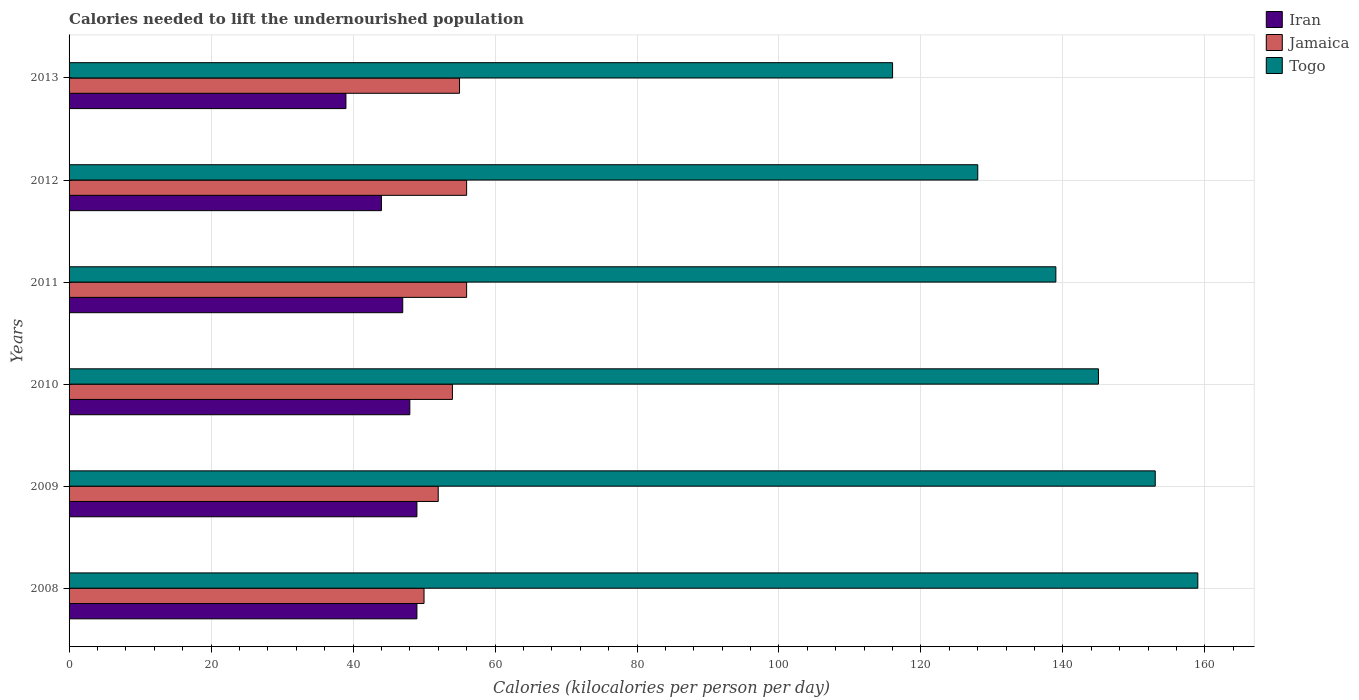How many different coloured bars are there?
Ensure brevity in your answer.  3. How many groups of bars are there?
Offer a very short reply. 6. Are the number of bars per tick equal to the number of legend labels?
Give a very brief answer. Yes. Are the number of bars on each tick of the Y-axis equal?
Offer a terse response. Yes. How many bars are there on the 1st tick from the top?
Give a very brief answer. 3. How many bars are there on the 2nd tick from the bottom?
Make the answer very short. 3. What is the label of the 6th group of bars from the top?
Provide a succinct answer. 2008. In how many cases, is the number of bars for a given year not equal to the number of legend labels?
Your response must be concise. 0. What is the total calories needed to lift the undernourished population in Togo in 2009?
Your answer should be very brief. 153. Across all years, what is the maximum total calories needed to lift the undernourished population in Jamaica?
Your answer should be very brief. 56. Across all years, what is the minimum total calories needed to lift the undernourished population in Iran?
Your answer should be very brief. 39. In which year was the total calories needed to lift the undernourished population in Iran maximum?
Provide a short and direct response. 2008. In which year was the total calories needed to lift the undernourished population in Togo minimum?
Offer a very short reply. 2013. What is the total total calories needed to lift the undernourished population in Iran in the graph?
Give a very brief answer. 276. What is the difference between the total calories needed to lift the undernourished population in Togo in 2008 and that in 2012?
Ensure brevity in your answer.  31. What is the difference between the total calories needed to lift the undernourished population in Iran in 2009 and the total calories needed to lift the undernourished population in Jamaica in 2008?
Offer a terse response. -1. In the year 2008, what is the difference between the total calories needed to lift the undernourished population in Togo and total calories needed to lift the undernourished population in Jamaica?
Provide a short and direct response. 109. What is the ratio of the total calories needed to lift the undernourished population in Togo in 2011 to that in 2012?
Your answer should be very brief. 1.09. What is the difference between the highest and the second highest total calories needed to lift the undernourished population in Iran?
Your response must be concise. 0. What is the difference between the highest and the lowest total calories needed to lift the undernourished population in Togo?
Provide a short and direct response. 43. In how many years, is the total calories needed to lift the undernourished population in Iran greater than the average total calories needed to lift the undernourished population in Iran taken over all years?
Provide a succinct answer. 4. Is the sum of the total calories needed to lift the undernourished population in Iran in 2011 and 2013 greater than the maximum total calories needed to lift the undernourished population in Togo across all years?
Make the answer very short. No. What does the 1st bar from the top in 2010 represents?
Make the answer very short. Togo. What does the 2nd bar from the bottom in 2010 represents?
Provide a short and direct response. Jamaica. How many bars are there?
Offer a very short reply. 18. Are all the bars in the graph horizontal?
Provide a short and direct response. Yes. How many years are there in the graph?
Provide a short and direct response. 6. What is the difference between two consecutive major ticks on the X-axis?
Keep it short and to the point. 20. Are the values on the major ticks of X-axis written in scientific E-notation?
Your answer should be very brief. No. Does the graph contain any zero values?
Provide a succinct answer. No. Does the graph contain grids?
Your answer should be compact. Yes. What is the title of the graph?
Your answer should be compact. Calories needed to lift the undernourished population. Does "Spain" appear as one of the legend labels in the graph?
Offer a terse response. No. What is the label or title of the X-axis?
Provide a short and direct response. Calories (kilocalories per person per day). What is the label or title of the Y-axis?
Your answer should be compact. Years. What is the Calories (kilocalories per person per day) of Iran in 2008?
Keep it short and to the point. 49. What is the Calories (kilocalories per person per day) in Togo in 2008?
Give a very brief answer. 159. What is the Calories (kilocalories per person per day) in Jamaica in 2009?
Your response must be concise. 52. What is the Calories (kilocalories per person per day) of Togo in 2009?
Give a very brief answer. 153. What is the Calories (kilocalories per person per day) of Iran in 2010?
Ensure brevity in your answer.  48. What is the Calories (kilocalories per person per day) of Togo in 2010?
Provide a short and direct response. 145. What is the Calories (kilocalories per person per day) in Jamaica in 2011?
Make the answer very short. 56. What is the Calories (kilocalories per person per day) of Togo in 2011?
Provide a succinct answer. 139. What is the Calories (kilocalories per person per day) of Iran in 2012?
Offer a terse response. 44. What is the Calories (kilocalories per person per day) of Jamaica in 2012?
Make the answer very short. 56. What is the Calories (kilocalories per person per day) in Togo in 2012?
Provide a succinct answer. 128. What is the Calories (kilocalories per person per day) of Jamaica in 2013?
Your answer should be very brief. 55. What is the Calories (kilocalories per person per day) of Togo in 2013?
Provide a short and direct response. 116. Across all years, what is the maximum Calories (kilocalories per person per day) in Togo?
Offer a terse response. 159. Across all years, what is the minimum Calories (kilocalories per person per day) of Iran?
Your answer should be compact. 39. Across all years, what is the minimum Calories (kilocalories per person per day) in Jamaica?
Ensure brevity in your answer.  50. Across all years, what is the minimum Calories (kilocalories per person per day) in Togo?
Keep it short and to the point. 116. What is the total Calories (kilocalories per person per day) of Iran in the graph?
Offer a terse response. 276. What is the total Calories (kilocalories per person per day) of Jamaica in the graph?
Ensure brevity in your answer.  323. What is the total Calories (kilocalories per person per day) of Togo in the graph?
Provide a short and direct response. 840. What is the difference between the Calories (kilocalories per person per day) in Jamaica in 2008 and that in 2009?
Provide a succinct answer. -2. What is the difference between the Calories (kilocalories per person per day) of Togo in 2008 and that in 2009?
Keep it short and to the point. 6. What is the difference between the Calories (kilocalories per person per day) in Iran in 2008 and that in 2010?
Your answer should be compact. 1. What is the difference between the Calories (kilocalories per person per day) of Togo in 2008 and that in 2010?
Offer a terse response. 14. What is the difference between the Calories (kilocalories per person per day) in Togo in 2008 and that in 2011?
Offer a very short reply. 20. What is the difference between the Calories (kilocalories per person per day) in Iran in 2008 and that in 2012?
Provide a succinct answer. 5. What is the difference between the Calories (kilocalories per person per day) of Togo in 2008 and that in 2012?
Your response must be concise. 31. What is the difference between the Calories (kilocalories per person per day) in Iran in 2009 and that in 2011?
Give a very brief answer. 2. What is the difference between the Calories (kilocalories per person per day) of Jamaica in 2009 and that in 2011?
Offer a terse response. -4. What is the difference between the Calories (kilocalories per person per day) in Iran in 2009 and that in 2012?
Offer a very short reply. 5. What is the difference between the Calories (kilocalories per person per day) of Jamaica in 2009 and that in 2012?
Provide a succinct answer. -4. What is the difference between the Calories (kilocalories per person per day) of Iran in 2009 and that in 2013?
Give a very brief answer. 10. What is the difference between the Calories (kilocalories per person per day) of Jamaica in 2009 and that in 2013?
Make the answer very short. -3. What is the difference between the Calories (kilocalories per person per day) in Iran in 2010 and that in 2011?
Provide a succinct answer. 1. What is the difference between the Calories (kilocalories per person per day) of Togo in 2010 and that in 2011?
Provide a short and direct response. 6. What is the difference between the Calories (kilocalories per person per day) of Togo in 2010 and that in 2012?
Your answer should be very brief. 17. What is the difference between the Calories (kilocalories per person per day) in Iran in 2010 and that in 2013?
Your answer should be very brief. 9. What is the difference between the Calories (kilocalories per person per day) in Jamaica in 2010 and that in 2013?
Ensure brevity in your answer.  -1. What is the difference between the Calories (kilocalories per person per day) of Iran in 2011 and that in 2012?
Your answer should be compact. 3. What is the difference between the Calories (kilocalories per person per day) of Jamaica in 2011 and that in 2013?
Your response must be concise. 1. What is the difference between the Calories (kilocalories per person per day) in Iran in 2012 and that in 2013?
Your answer should be very brief. 5. What is the difference between the Calories (kilocalories per person per day) in Togo in 2012 and that in 2013?
Your answer should be compact. 12. What is the difference between the Calories (kilocalories per person per day) of Iran in 2008 and the Calories (kilocalories per person per day) of Jamaica in 2009?
Make the answer very short. -3. What is the difference between the Calories (kilocalories per person per day) of Iran in 2008 and the Calories (kilocalories per person per day) of Togo in 2009?
Your answer should be compact. -104. What is the difference between the Calories (kilocalories per person per day) of Jamaica in 2008 and the Calories (kilocalories per person per day) of Togo in 2009?
Keep it short and to the point. -103. What is the difference between the Calories (kilocalories per person per day) of Iran in 2008 and the Calories (kilocalories per person per day) of Jamaica in 2010?
Provide a succinct answer. -5. What is the difference between the Calories (kilocalories per person per day) of Iran in 2008 and the Calories (kilocalories per person per day) of Togo in 2010?
Ensure brevity in your answer.  -96. What is the difference between the Calories (kilocalories per person per day) of Jamaica in 2008 and the Calories (kilocalories per person per day) of Togo in 2010?
Your answer should be very brief. -95. What is the difference between the Calories (kilocalories per person per day) of Iran in 2008 and the Calories (kilocalories per person per day) of Jamaica in 2011?
Offer a very short reply. -7. What is the difference between the Calories (kilocalories per person per day) in Iran in 2008 and the Calories (kilocalories per person per day) in Togo in 2011?
Your answer should be compact. -90. What is the difference between the Calories (kilocalories per person per day) of Jamaica in 2008 and the Calories (kilocalories per person per day) of Togo in 2011?
Your answer should be compact. -89. What is the difference between the Calories (kilocalories per person per day) of Iran in 2008 and the Calories (kilocalories per person per day) of Jamaica in 2012?
Make the answer very short. -7. What is the difference between the Calories (kilocalories per person per day) of Iran in 2008 and the Calories (kilocalories per person per day) of Togo in 2012?
Your response must be concise. -79. What is the difference between the Calories (kilocalories per person per day) of Jamaica in 2008 and the Calories (kilocalories per person per day) of Togo in 2012?
Your response must be concise. -78. What is the difference between the Calories (kilocalories per person per day) of Iran in 2008 and the Calories (kilocalories per person per day) of Togo in 2013?
Give a very brief answer. -67. What is the difference between the Calories (kilocalories per person per day) of Jamaica in 2008 and the Calories (kilocalories per person per day) of Togo in 2013?
Give a very brief answer. -66. What is the difference between the Calories (kilocalories per person per day) in Iran in 2009 and the Calories (kilocalories per person per day) in Jamaica in 2010?
Make the answer very short. -5. What is the difference between the Calories (kilocalories per person per day) of Iran in 2009 and the Calories (kilocalories per person per day) of Togo in 2010?
Your answer should be very brief. -96. What is the difference between the Calories (kilocalories per person per day) in Jamaica in 2009 and the Calories (kilocalories per person per day) in Togo in 2010?
Provide a short and direct response. -93. What is the difference between the Calories (kilocalories per person per day) in Iran in 2009 and the Calories (kilocalories per person per day) in Togo in 2011?
Keep it short and to the point. -90. What is the difference between the Calories (kilocalories per person per day) of Jamaica in 2009 and the Calories (kilocalories per person per day) of Togo in 2011?
Give a very brief answer. -87. What is the difference between the Calories (kilocalories per person per day) in Iran in 2009 and the Calories (kilocalories per person per day) in Jamaica in 2012?
Give a very brief answer. -7. What is the difference between the Calories (kilocalories per person per day) in Iran in 2009 and the Calories (kilocalories per person per day) in Togo in 2012?
Your answer should be very brief. -79. What is the difference between the Calories (kilocalories per person per day) of Jamaica in 2009 and the Calories (kilocalories per person per day) of Togo in 2012?
Provide a short and direct response. -76. What is the difference between the Calories (kilocalories per person per day) in Iran in 2009 and the Calories (kilocalories per person per day) in Togo in 2013?
Make the answer very short. -67. What is the difference between the Calories (kilocalories per person per day) in Jamaica in 2009 and the Calories (kilocalories per person per day) in Togo in 2013?
Your answer should be compact. -64. What is the difference between the Calories (kilocalories per person per day) in Iran in 2010 and the Calories (kilocalories per person per day) in Togo in 2011?
Provide a short and direct response. -91. What is the difference between the Calories (kilocalories per person per day) of Jamaica in 2010 and the Calories (kilocalories per person per day) of Togo in 2011?
Make the answer very short. -85. What is the difference between the Calories (kilocalories per person per day) in Iran in 2010 and the Calories (kilocalories per person per day) in Togo in 2012?
Make the answer very short. -80. What is the difference between the Calories (kilocalories per person per day) in Jamaica in 2010 and the Calories (kilocalories per person per day) in Togo in 2012?
Your answer should be very brief. -74. What is the difference between the Calories (kilocalories per person per day) in Iran in 2010 and the Calories (kilocalories per person per day) in Togo in 2013?
Offer a terse response. -68. What is the difference between the Calories (kilocalories per person per day) in Jamaica in 2010 and the Calories (kilocalories per person per day) in Togo in 2013?
Your answer should be very brief. -62. What is the difference between the Calories (kilocalories per person per day) of Iran in 2011 and the Calories (kilocalories per person per day) of Togo in 2012?
Give a very brief answer. -81. What is the difference between the Calories (kilocalories per person per day) of Jamaica in 2011 and the Calories (kilocalories per person per day) of Togo in 2012?
Give a very brief answer. -72. What is the difference between the Calories (kilocalories per person per day) of Iran in 2011 and the Calories (kilocalories per person per day) of Togo in 2013?
Give a very brief answer. -69. What is the difference between the Calories (kilocalories per person per day) in Jamaica in 2011 and the Calories (kilocalories per person per day) in Togo in 2013?
Your response must be concise. -60. What is the difference between the Calories (kilocalories per person per day) of Iran in 2012 and the Calories (kilocalories per person per day) of Togo in 2013?
Ensure brevity in your answer.  -72. What is the difference between the Calories (kilocalories per person per day) in Jamaica in 2012 and the Calories (kilocalories per person per day) in Togo in 2013?
Make the answer very short. -60. What is the average Calories (kilocalories per person per day) of Iran per year?
Give a very brief answer. 46. What is the average Calories (kilocalories per person per day) in Jamaica per year?
Keep it short and to the point. 53.83. What is the average Calories (kilocalories per person per day) in Togo per year?
Ensure brevity in your answer.  140. In the year 2008, what is the difference between the Calories (kilocalories per person per day) in Iran and Calories (kilocalories per person per day) in Togo?
Offer a very short reply. -110. In the year 2008, what is the difference between the Calories (kilocalories per person per day) of Jamaica and Calories (kilocalories per person per day) of Togo?
Offer a very short reply. -109. In the year 2009, what is the difference between the Calories (kilocalories per person per day) in Iran and Calories (kilocalories per person per day) in Togo?
Offer a very short reply. -104. In the year 2009, what is the difference between the Calories (kilocalories per person per day) of Jamaica and Calories (kilocalories per person per day) of Togo?
Offer a very short reply. -101. In the year 2010, what is the difference between the Calories (kilocalories per person per day) of Iran and Calories (kilocalories per person per day) of Jamaica?
Offer a terse response. -6. In the year 2010, what is the difference between the Calories (kilocalories per person per day) in Iran and Calories (kilocalories per person per day) in Togo?
Provide a succinct answer. -97. In the year 2010, what is the difference between the Calories (kilocalories per person per day) in Jamaica and Calories (kilocalories per person per day) in Togo?
Your answer should be very brief. -91. In the year 2011, what is the difference between the Calories (kilocalories per person per day) of Iran and Calories (kilocalories per person per day) of Togo?
Provide a succinct answer. -92. In the year 2011, what is the difference between the Calories (kilocalories per person per day) of Jamaica and Calories (kilocalories per person per day) of Togo?
Provide a succinct answer. -83. In the year 2012, what is the difference between the Calories (kilocalories per person per day) of Iran and Calories (kilocalories per person per day) of Jamaica?
Provide a succinct answer. -12. In the year 2012, what is the difference between the Calories (kilocalories per person per day) of Iran and Calories (kilocalories per person per day) of Togo?
Keep it short and to the point. -84. In the year 2012, what is the difference between the Calories (kilocalories per person per day) in Jamaica and Calories (kilocalories per person per day) in Togo?
Provide a short and direct response. -72. In the year 2013, what is the difference between the Calories (kilocalories per person per day) of Iran and Calories (kilocalories per person per day) of Togo?
Give a very brief answer. -77. In the year 2013, what is the difference between the Calories (kilocalories per person per day) of Jamaica and Calories (kilocalories per person per day) of Togo?
Your answer should be very brief. -61. What is the ratio of the Calories (kilocalories per person per day) of Jamaica in 2008 to that in 2009?
Your answer should be very brief. 0.96. What is the ratio of the Calories (kilocalories per person per day) in Togo in 2008 to that in 2009?
Your answer should be compact. 1.04. What is the ratio of the Calories (kilocalories per person per day) in Iran in 2008 to that in 2010?
Provide a succinct answer. 1.02. What is the ratio of the Calories (kilocalories per person per day) in Jamaica in 2008 to that in 2010?
Provide a succinct answer. 0.93. What is the ratio of the Calories (kilocalories per person per day) of Togo in 2008 to that in 2010?
Your answer should be very brief. 1.1. What is the ratio of the Calories (kilocalories per person per day) of Iran in 2008 to that in 2011?
Your answer should be compact. 1.04. What is the ratio of the Calories (kilocalories per person per day) in Jamaica in 2008 to that in 2011?
Your answer should be compact. 0.89. What is the ratio of the Calories (kilocalories per person per day) of Togo in 2008 to that in 2011?
Offer a very short reply. 1.14. What is the ratio of the Calories (kilocalories per person per day) of Iran in 2008 to that in 2012?
Your answer should be very brief. 1.11. What is the ratio of the Calories (kilocalories per person per day) in Jamaica in 2008 to that in 2012?
Keep it short and to the point. 0.89. What is the ratio of the Calories (kilocalories per person per day) in Togo in 2008 to that in 2012?
Offer a very short reply. 1.24. What is the ratio of the Calories (kilocalories per person per day) of Iran in 2008 to that in 2013?
Your answer should be very brief. 1.26. What is the ratio of the Calories (kilocalories per person per day) of Togo in 2008 to that in 2013?
Your answer should be compact. 1.37. What is the ratio of the Calories (kilocalories per person per day) in Iran in 2009 to that in 2010?
Ensure brevity in your answer.  1.02. What is the ratio of the Calories (kilocalories per person per day) of Togo in 2009 to that in 2010?
Ensure brevity in your answer.  1.06. What is the ratio of the Calories (kilocalories per person per day) in Iran in 2009 to that in 2011?
Provide a succinct answer. 1.04. What is the ratio of the Calories (kilocalories per person per day) of Jamaica in 2009 to that in 2011?
Give a very brief answer. 0.93. What is the ratio of the Calories (kilocalories per person per day) of Togo in 2009 to that in 2011?
Make the answer very short. 1.1. What is the ratio of the Calories (kilocalories per person per day) of Iran in 2009 to that in 2012?
Ensure brevity in your answer.  1.11. What is the ratio of the Calories (kilocalories per person per day) in Jamaica in 2009 to that in 2012?
Your answer should be very brief. 0.93. What is the ratio of the Calories (kilocalories per person per day) in Togo in 2009 to that in 2012?
Keep it short and to the point. 1.2. What is the ratio of the Calories (kilocalories per person per day) of Iran in 2009 to that in 2013?
Offer a terse response. 1.26. What is the ratio of the Calories (kilocalories per person per day) in Jamaica in 2009 to that in 2013?
Offer a terse response. 0.95. What is the ratio of the Calories (kilocalories per person per day) of Togo in 2009 to that in 2013?
Provide a succinct answer. 1.32. What is the ratio of the Calories (kilocalories per person per day) of Iran in 2010 to that in 2011?
Offer a terse response. 1.02. What is the ratio of the Calories (kilocalories per person per day) in Jamaica in 2010 to that in 2011?
Provide a short and direct response. 0.96. What is the ratio of the Calories (kilocalories per person per day) of Togo in 2010 to that in 2011?
Your answer should be very brief. 1.04. What is the ratio of the Calories (kilocalories per person per day) of Togo in 2010 to that in 2012?
Keep it short and to the point. 1.13. What is the ratio of the Calories (kilocalories per person per day) in Iran in 2010 to that in 2013?
Your answer should be compact. 1.23. What is the ratio of the Calories (kilocalories per person per day) in Jamaica in 2010 to that in 2013?
Keep it short and to the point. 0.98. What is the ratio of the Calories (kilocalories per person per day) of Togo in 2010 to that in 2013?
Your answer should be very brief. 1.25. What is the ratio of the Calories (kilocalories per person per day) of Iran in 2011 to that in 2012?
Provide a succinct answer. 1.07. What is the ratio of the Calories (kilocalories per person per day) of Jamaica in 2011 to that in 2012?
Your response must be concise. 1. What is the ratio of the Calories (kilocalories per person per day) in Togo in 2011 to that in 2012?
Make the answer very short. 1.09. What is the ratio of the Calories (kilocalories per person per day) of Iran in 2011 to that in 2013?
Your answer should be very brief. 1.21. What is the ratio of the Calories (kilocalories per person per day) of Jamaica in 2011 to that in 2013?
Give a very brief answer. 1.02. What is the ratio of the Calories (kilocalories per person per day) in Togo in 2011 to that in 2013?
Offer a terse response. 1.2. What is the ratio of the Calories (kilocalories per person per day) in Iran in 2012 to that in 2013?
Provide a short and direct response. 1.13. What is the ratio of the Calories (kilocalories per person per day) in Jamaica in 2012 to that in 2013?
Your response must be concise. 1.02. What is the ratio of the Calories (kilocalories per person per day) in Togo in 2012 to that in 2013?
Keep it short and to the point. 1.1. What is the difference between the highest and the second highest Calories (kilocalories per person per day) in Iran?
Give a very brief answer. 0. What is the difference between the highest and the lowest Calories (kilocalories per person per day) of Iran?
Provide a short and direct response. 10. What is the difference between the highest and the lowest Calories (kilocalories per person per day) in Jamaica?
Offer a terse response. 6. 